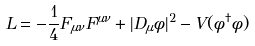<formula> <loc_0><loc_0><loc_500><loc_500>L = - \frac { 1 } { 4 } F _ { \mu \nu } F ^ { \mu \nu } + | D _ { \mu } \phi | ^ { 2 } - V ( \phi ^ { \dagger } \phi )</formula> 